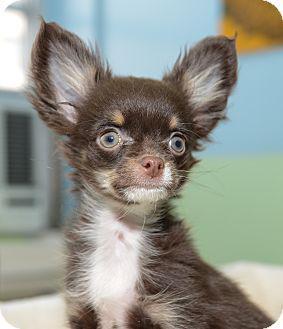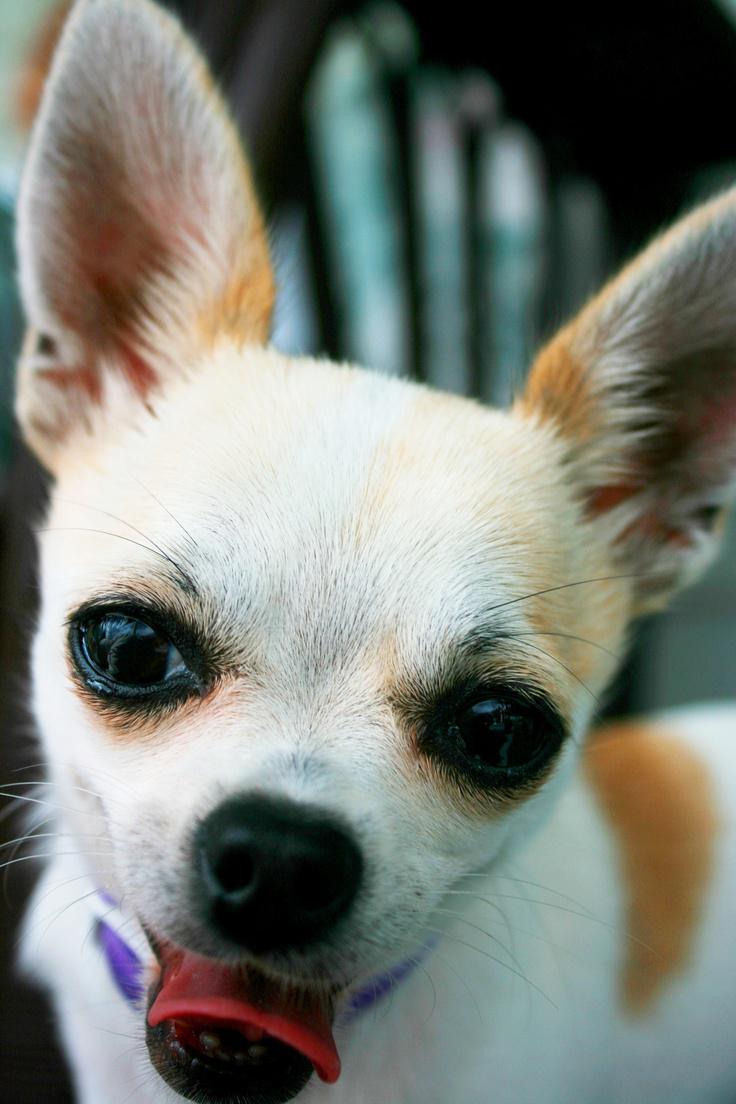The first image is the image on the left, the second image is the image on the right. Considering the images on both sides, is "An image shows a dog with its tongue sticking out." valid? Answer yes or no. Yes. The first image is the image on the left, the second image is the image on the right. Assess this claim about the two images: "Two little dogs have eyes wide open, but only one of them is showing his tongue.". Correct or not? Answer yes or no. Yes. The first image is the image on the left, the second image is the image on the right. Considering the images on both sides, is "One of the images shows a dog with its tongue sticking out." valid? Answer yes or no. Yes. 